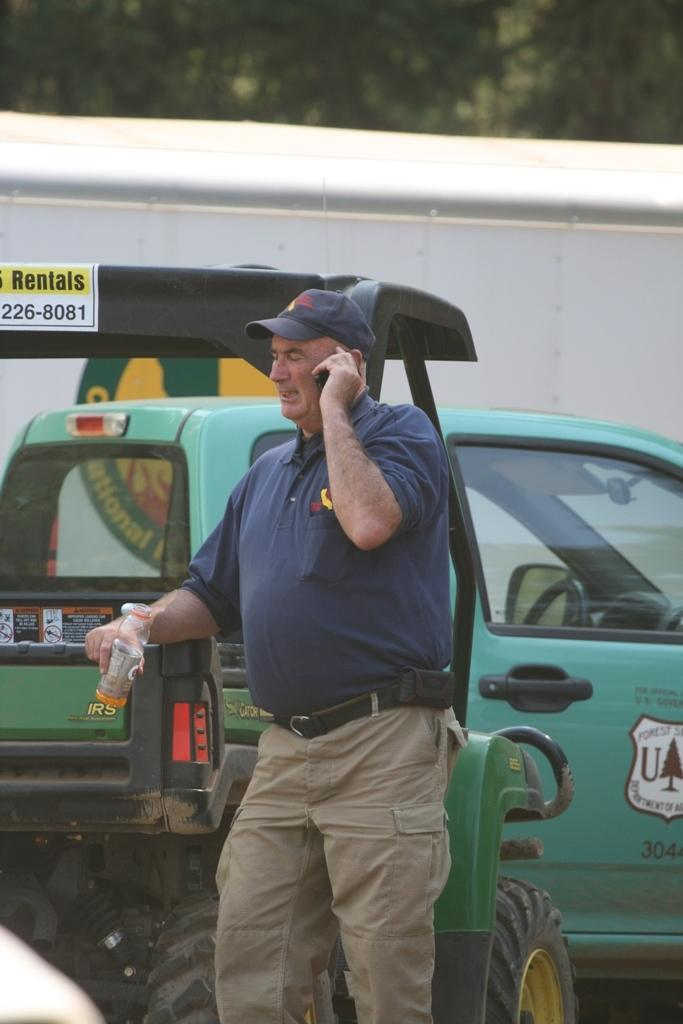Who is present in the image? There is a man in the image. What is the man wearing on his head? The man is wearing a cap. What is the man holding in his hand? The man is holding a bottle. What is the man's posture in the image? The man is standing. What can be seen in the background of the image? There are trees in the background of the image. What else is visible in the image besides the man and trees? There are vehicles in the image. How many kittens are sitting on the man's shoulder in the image? There are no kittens present in the image. What type of comb is the man using to style his hair in the image? There is no comb visible in the image, and the man's hair is not being styled. 